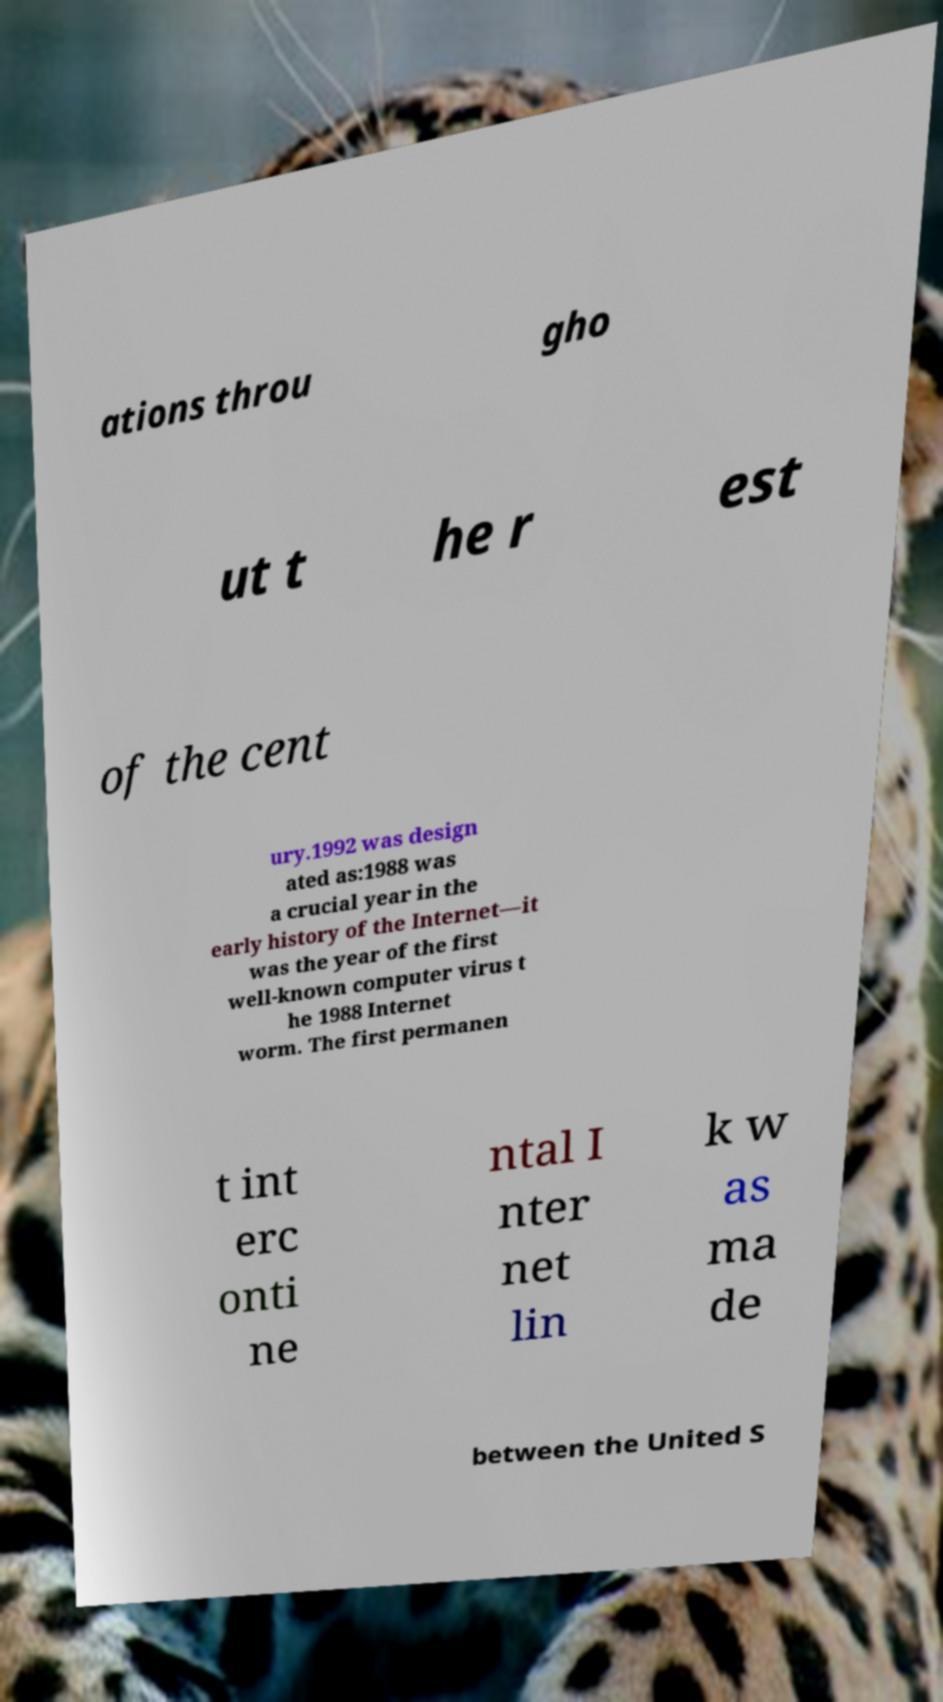Please identify and transcribe the text found in this image. ations throu gho ut t he r est of the cent ury.1992 was design ated as:1988 was a crucial year in the early history of the Internet—it was the year of the first well-known computer virus t he 1988 Internet worm. The first permanen t int erc onti ne ntal I nter net lin k w as ma de between the United S 